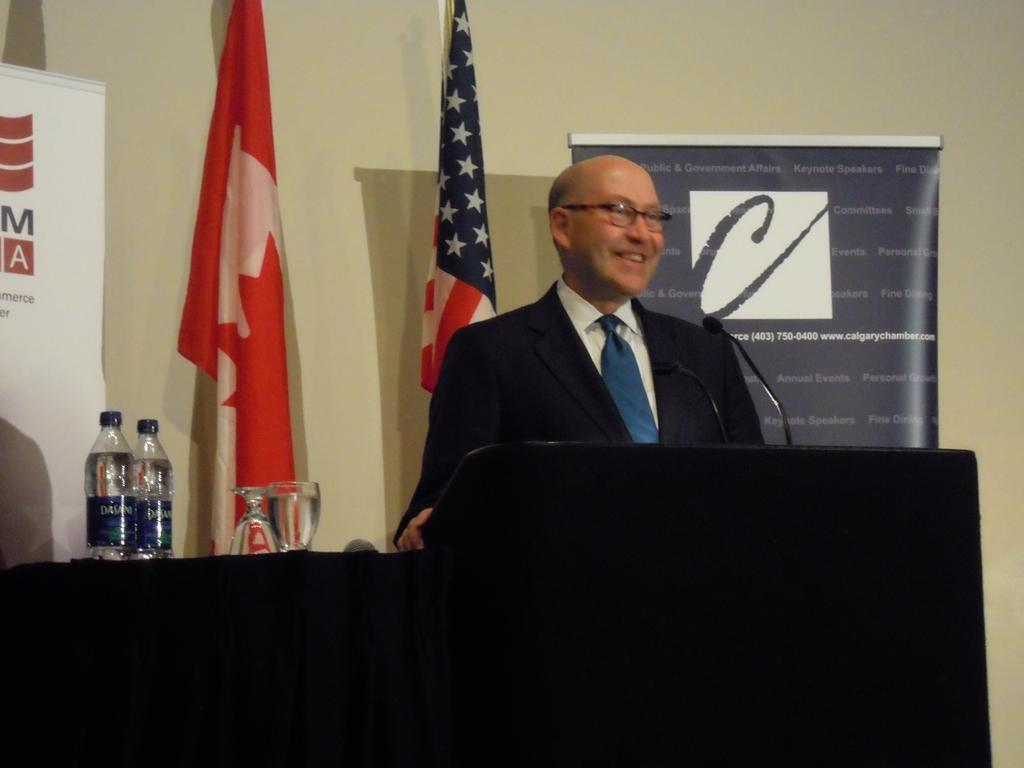Who is present in the image? There is a man in the image. What is the man wearing in the image? The man is wearing a coat and a tie. What is the man doing in the image? The man is speaking into a microphone. What else can be seen in the image? There are water bottles visible in the image. What type of cattle can be seen grazing in the garden behind the man in the image? There is no cattle or garden present in the image; it features a man speaking into a microphone and water bottles. How does the acoustics of the room affect the man's speech in the image? The provided facts do not mention any information about the room's acoustics, so it cannot be determined how it affects the man's speech. 